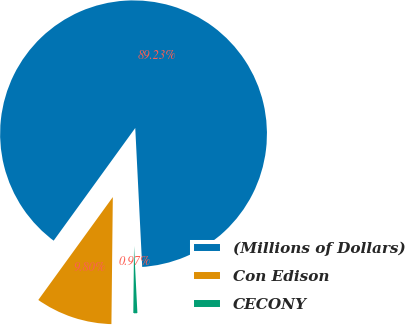<chart> <loc_0><loc_0><loc_500><loc_500><pie_chart><fcel>(Millions of Dollars)<fcel>Con Edison<fcel>CECONY<nl><fcel>89.23%<fcel>9.8%<fcel>0.97%<nl></chart> 